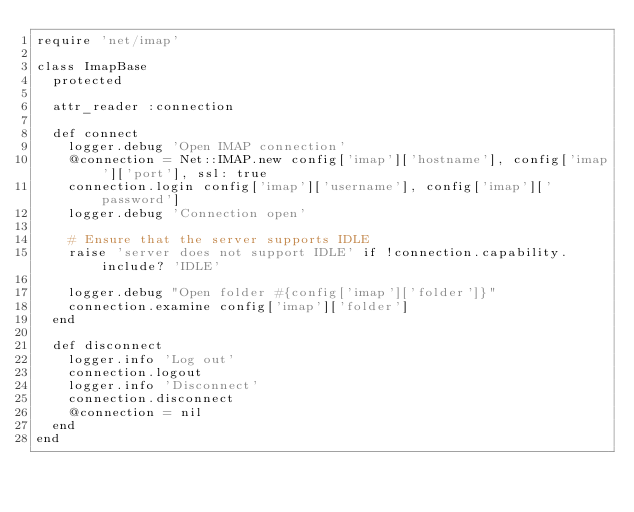Convert code to text. <code><loc_0><loc_0><loc_500><loc_500><_Ruby_>require 'net/imap'

class ImapBase
  protected

  attr_reader :connection

  def connect
    logger.debug 'Open IMAP connection'
    @connection = Net::IMAP.new config['imap']['hostname'], config['imap']['port'], ssl: true
    connection.login config['imap']['username'], config['imap']['password']
    logger.debug 'Connection open'

    # Ensure that the server supports IDLE
    raise 'server does not support IDLE' if !connection.capability.include? 'IDLE'

    logger.debug "Open folder #{config['imap']['folder']}"
    connection.examine config['imap']['folder']
  end

  def disconnect
    logger.info 'Log out'
    connection.logout
    logger.info 'Disconnect'
    connection.disconnect
    @connection = nil
  end
end
</code> 